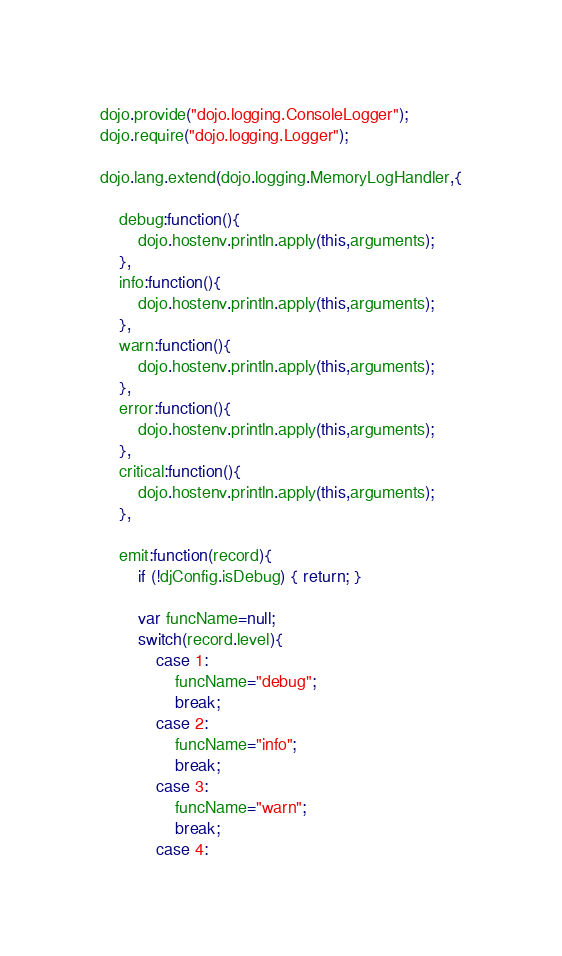<code> <loc_0><loc_0><loc_500><loc_500><_JavaScript_>dojo.provide("dojo.logging.ConsoleLogger");
dojo.require("dojo.logging.Logger");

dojo.lang.extend(dojo.logging.MemoryLogHandler,{
	
	debug:function(){
		dojo.hostenv.println.apply(this,arguments);
	},
	info:function(){
		dojo.hostenv.println.apply(this,arguments);
	},
	warn:function(){
		dojo.hostenv.println.apply(this,arguments);
	},
	error:function(){
		dojo.hostenv.println.apply(this,arguments);
	},
	critical:function(){
		dojo.hostenv.println.apply(this,arguments);
	},
	
	emit:function(record){
		if (!djConfig.isDebug) { return; }
		
		var funcName=null;
		switch(record.level){
			case 1:
				funcName="debug";
				break;
			case 2:
				funcName="info";
				break;
			case 3:
				funcName="warn";
				break;
			case 4:</code> 